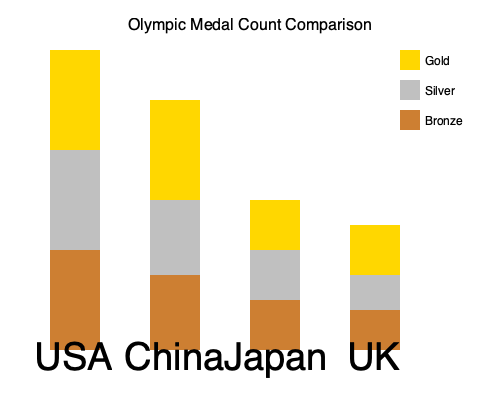Based on the stacked bar chart comparing Olympic medal counts, which country shows the most balanced distribution of medals across gold, silver, and bronze categories, potentially indicating a diverse range of athletic strengths? To determine which country has the most balanced distribution of medals, we need to analyze the relative proportions of gold, silver, and bronze medals for each country:

1. USA:
   - Large gold bar, medium silver bar, small bronze bar
   - Indicates a top-heavy distribution with more golds than silvers or bronzes

2. China:
   - Very large gold bar, medium silver bar, small bronze bar
   - Shows an even more pronounced focus on gold medals

3. Japan:
   - Gold, silver, and bronze bars are more similar in size
   - Suggests a more even distribution across medal types

4. UK:
   - Gold, silver, and bronze bars are closest in size among all countries
   - Indicates the most balanced distribution of medals

The UK's bar shows the most similar heights for gold, silver, and bronze medals, suggesting a more balanced performance across different events and disciplines. This balance could indicate a diverse range of athletic strengths, as success is spread more evenly across different types of competitions.

In contrast, countries like the USA and China show a clear emphasis on gold medals, which might indicate a focus on dominating specific events or sports.
Answer: United Kingdom (UK) 